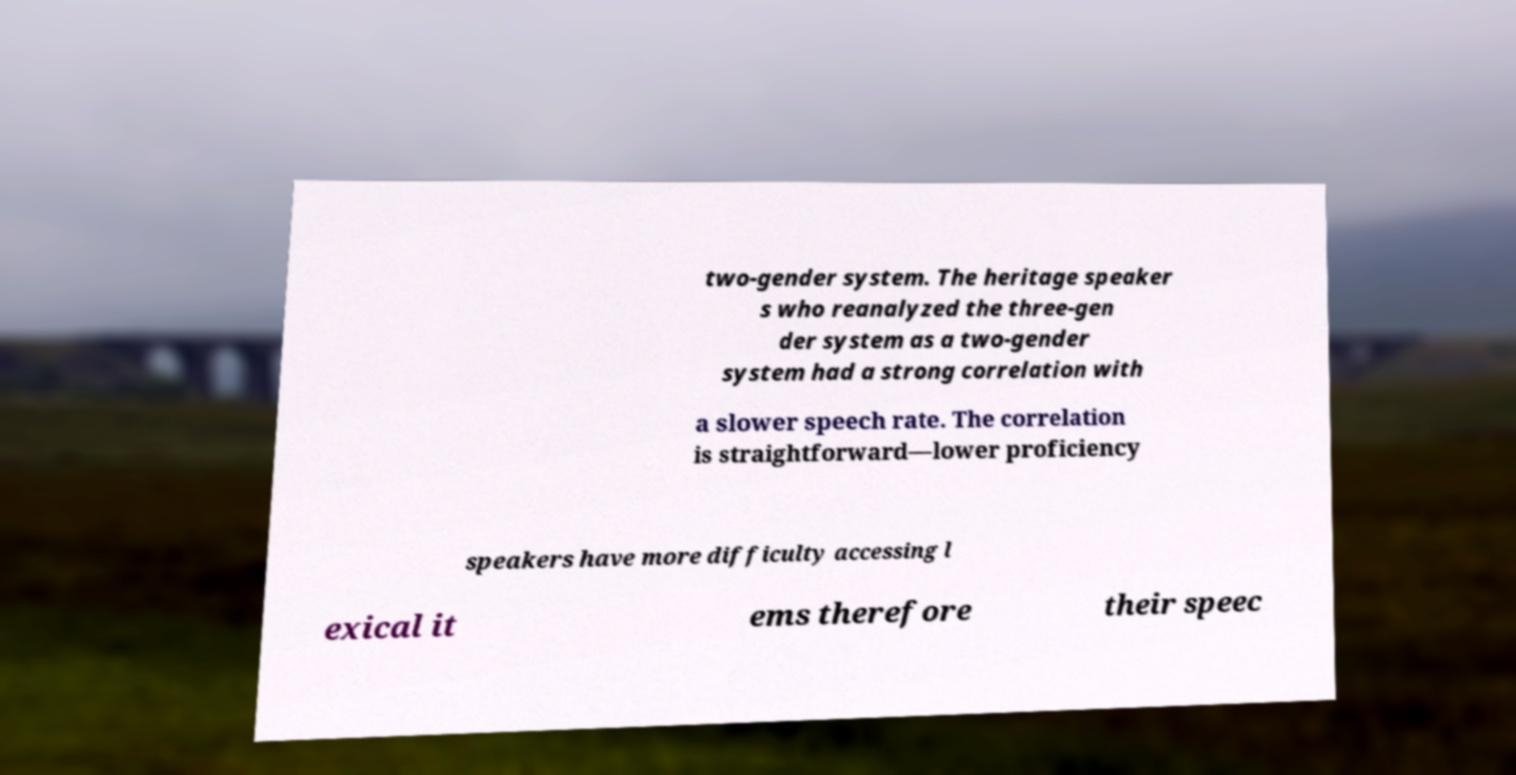Could you assist in decoding the text presented in this image and type it out clearly? two-gender system. The heritage speaker s who reanalyzed the three-gen der system as a two-gender system had a strong correlation with a slower speech rate. The correlation is straightforward—lower proficiency speakers have more difficulty accessing l exical it ems therefore their speec 